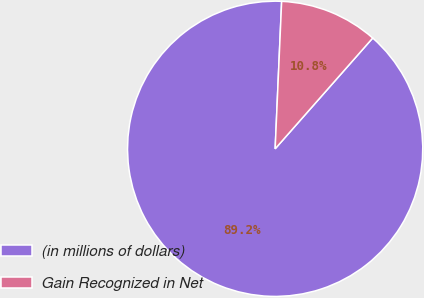<chart> <loc_0><loc_0><loc_500><loc_500><pie_chart><fcel>(in millions of dollars)<fcel>Gain Recognized in Net<nl><fcel>89.21%<fcel>10.79%<nl></chart> 